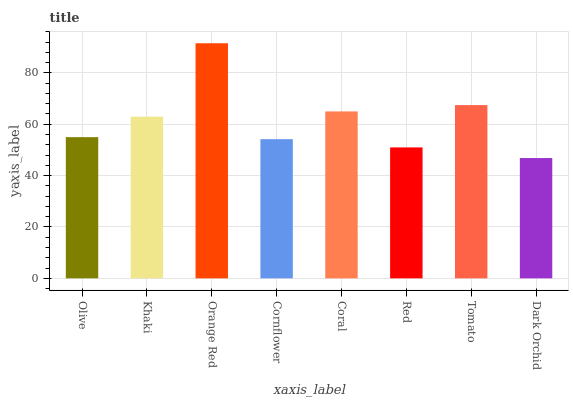Is Khaki the minimum?
Answer yes or no. No. Is Khaki the maximum?
Answer yes or no. No. Is Khaki greater than Olive?
Answer yes or no. Yes. Is Olive less than Khaki?
Answer yes or no. Yes. Is Olive greater than Khaki?
Answer yes or no. No. Is Khaki less than Olive?
Answer yes or no. No. Is Khaki the high median?
Answer yes or no. Yes. Is Olive the low median?
Answer yes or no. Yes. Is Orange Red the high median?
Answer yes or no. No. Is Orange Red the low median?
Answer yes or no. No. 